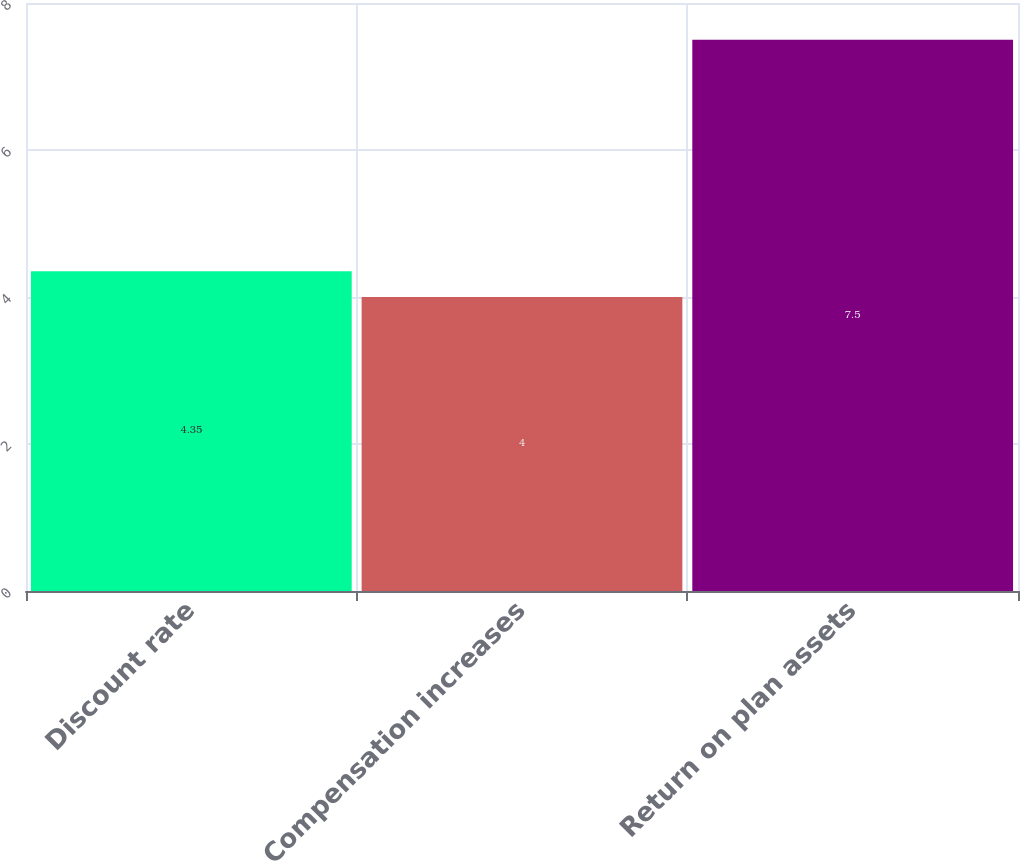Convert chart to OTSL. <chart><loc_0><loc_0><loc_500><loc_500><bar_chart><fcel>Discount rate<fcel>Compensation increases<fcel>Return on plan assets<nl><fcel>4.35<fcel>4<fcel>7.5<nl></chart> 